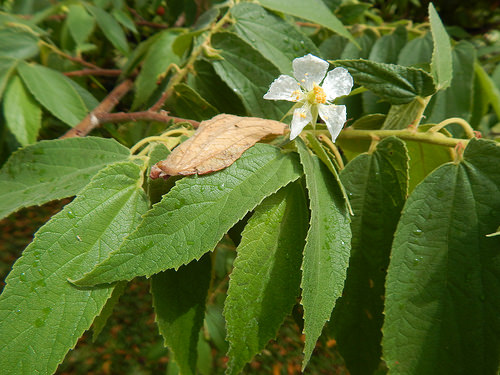<image>
Is there a bug in the flower? No. The bug is not contained within the flower. These objects have a different spatial relationship. 